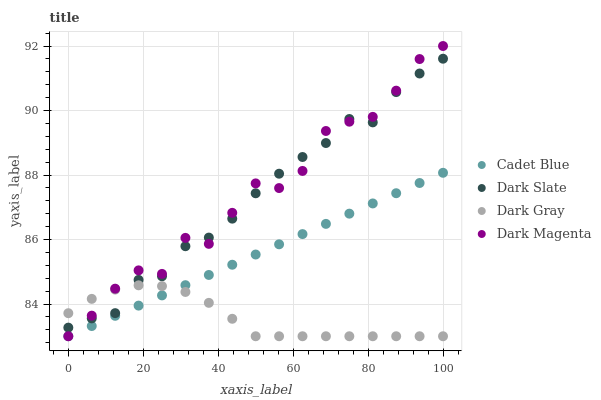Does Dark Gray have the minimum area under the curve?
Answer yes or no. Yes. Does Dark Magenta have the maximum area under the curve?
Answer yes or no. Yes. Does Dark Slate have the minimum area under the curve?
Answer yes or no. No. Does Dark Slate have the maximum area under the curve?
Answer yes or no. No. Is Cadet Blue the smoothest?
Answer yes or no. Yes. Is Dark Magenta the roughest?
Answer yes or no. Yes. Is Dark Slate the smoothest?
Answer yes or no. No. Is Dark Slate the roughest?
Answer yes or no. No. Does Dark Gray have the lowest value?
Answer yes or no. Yes. Does Dark Slate have the lowest value?
Answer yes or no. No. Does Dark Magenta have the highest value?
Answer yes or no. Yes. Does Dark Slate have the highest value?
Answer yes or no. No. Is Cadet Blue less than Dark Slate?
Answer yes or no. Yes. Is Dark Slate greater than Cadet Blue?
Answer yes or no. Yes. Does Dark Slate intersect Dark Gray?
Answer yes or no. Yes. Is Dark Slate less than Dark Gray?
Answer yes or no. No. Is Dark Slate greater than Dark Gray?
Answer yes or no. No. Does Cadet Blue intersect Dark Slate?
Answer yes or no. No. 